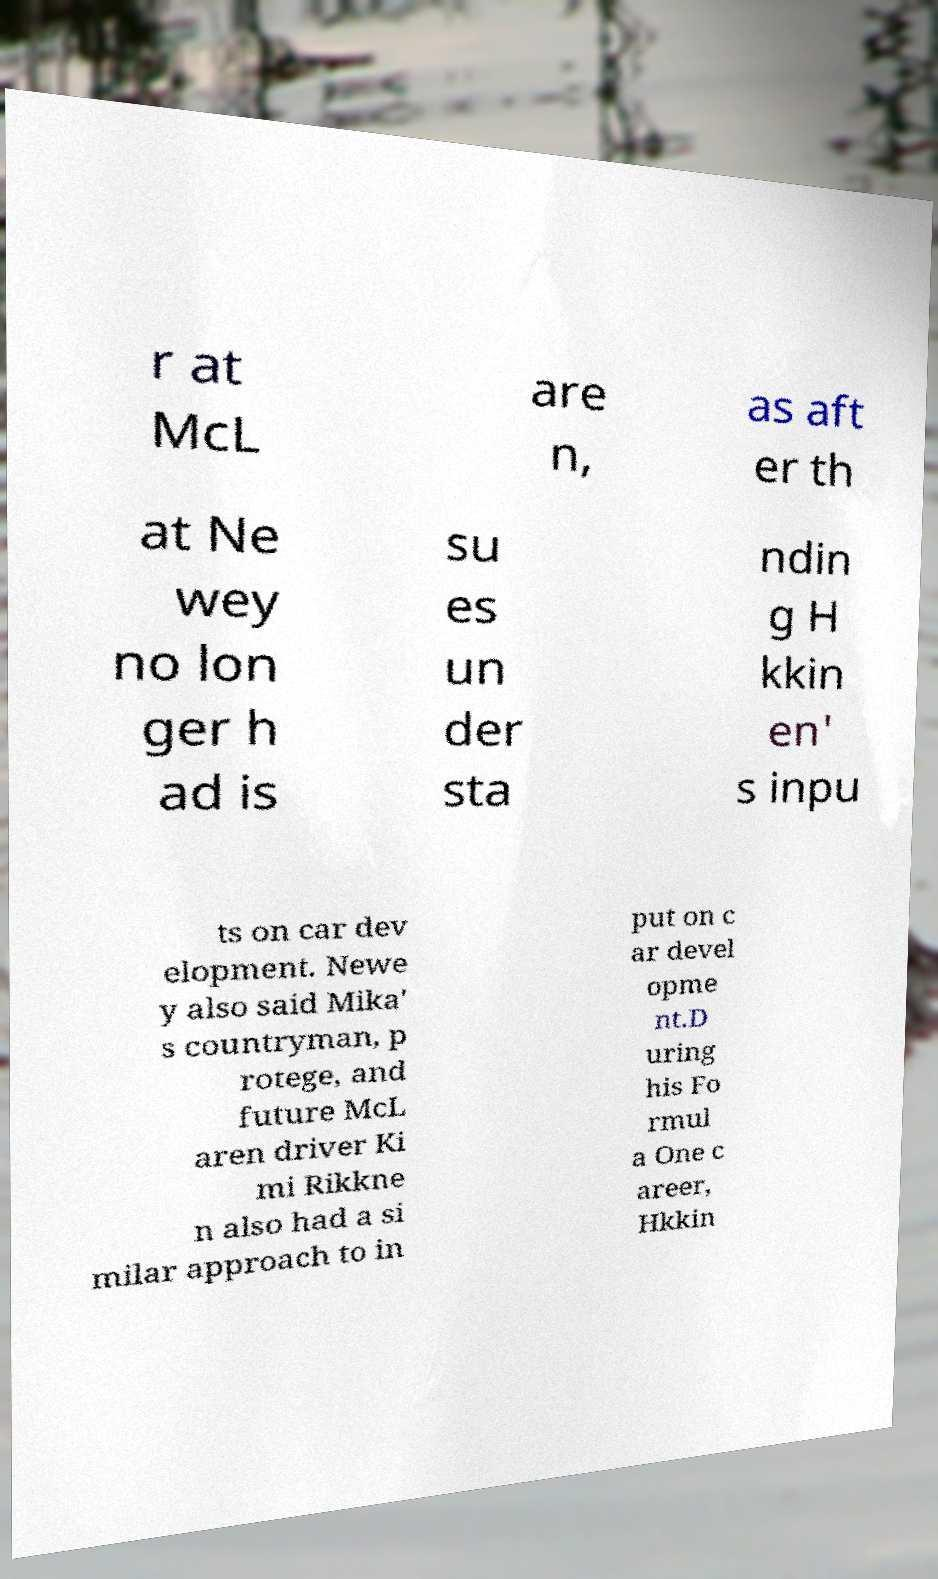What messages or text are displayed in this image? I need them in a readable, typed format. r at McL are n, as aft er th at Ne wey no lon ger h ad is su es un der sta ndin g H kkin en' s inpu ts on car dev elopment. Newe y also said Mika' s countryman, p rotege, and future McL aren driver Ki mi Rikkne n also had a si milar approach to in put on c ar devel opme nt.D uring his Fo rmul a One c areer, Hkkin 